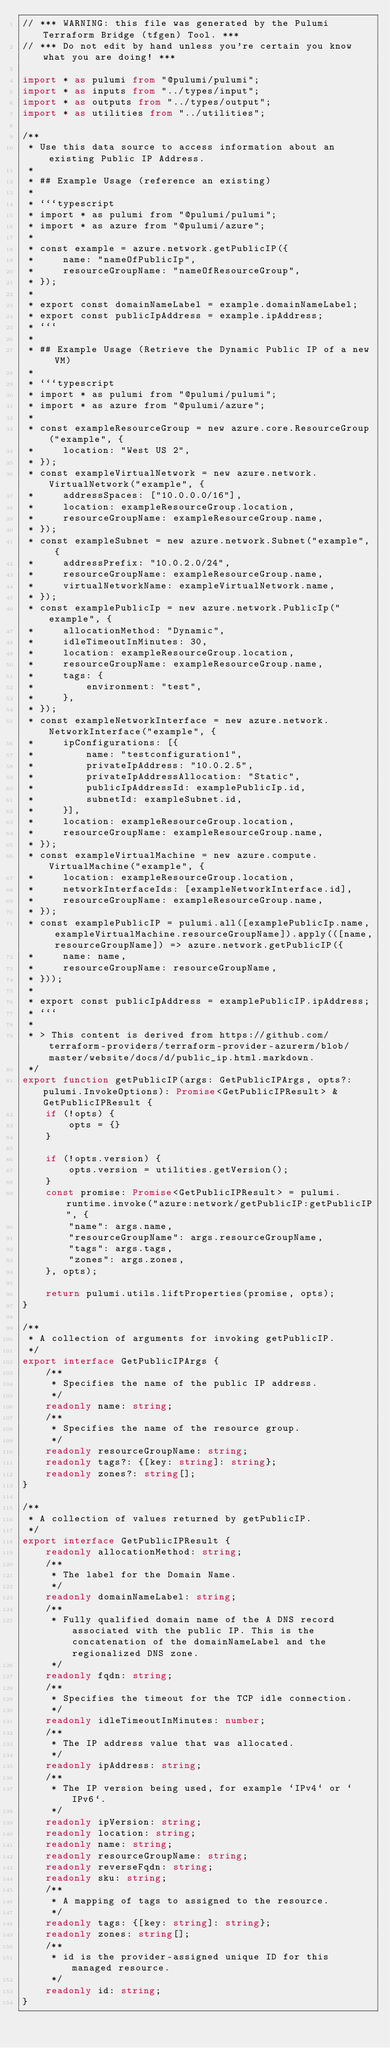Convert code to text. <code><loc_0><loc_0><loc_500><loc_500><_TypeScript_>// *** WARNING: this file was generated by the Pulumi Terraform Bridge (tfgen) Tool. ***
// *** Do not edit by hand unless you're certain you know what you are doing! ***

import * as pulumi from "@pulumi/pulumi";
import * as inputs from "../types/input";
import * as outputs from "../types/output";
import * as utilities from "../utilities";

/**
 * Use this data source to access information about an existing Public IP Address.
 * 
 * ## Example Usage (reference an existing)
 * 
 * ```typescript
 * import * as pulumi from "@pulumi/pulumi";
 * import * as azure from "@pulumi/azure";
 * 
 * const example = azure.network.getPublicIP({
 *     name: "nameOfPublicIp",
 *     resourceGroupName: "nameOfResourceGroup",
 * });
 * 
 * export const domainNameLabel = example.domainNameLabel;
 * export const publicIpAddress = example.ipAddress;
 * ```
 * 
 * ## Example Usage (Retrieve the Dynamic Public IP of a new VM)
 * 
 * ```typescript
 * import * as pulumi from "@pulumi/pulumi";
 * import * as azure from "@pulumi/azure";
 * 
 * const exampleResourceGroup = new azure.core.ResourceGroup("example", {
 *     location: "West US 2",
 * });
 * const exampleVirtualNetwork = new azure.network.VirtualNetwork("example", {
 *     addressSpaces: ["10.0.0.0/16"],
 *     location: exampleResourceGroup.location,
 *     resourceGroupName: exampleResourceGroup.name,
 * });
 * const exampleSubnet = new azure.network.Subnet("example", {
 *     addressPrefix: "10.0.2.0/24",
 *     resourceGroupName: exampleResourceGroup.name,
 *     virtualNetworkName: exampleVirtualNetwork.name,
 * });
 * const examplePublicIp = new azure.network.PublicIp("example", {
 *     allocationMethod: "Dynamic",
 *     idleTimeoutInMinutes: 30,
 *     location: exampleResourceGroup.location,
 *     resourceGroupName: exampleResourceGroup.name,
 *     tags: {
 *         environment: "test",
 *     },
 * });
 * const exampleNetworkInterface = new azure.network.NetworkInterface("example", {
 *     ipConfigurations: [{
 *         name: "testconfiguration1",
 *         privateIpAddress: "10.0.2.5",
 *         privateIpAddressAllocation: "Static",
 *         publicIpAddressId: examplePublicIp.id,
 *         subnetId: exampleSubnet.id,
 *     }],
 *     location: exampleResourceGroup.location,
 *     resourceGroupName: exampleResourceGroup.name,
 * });
 * const exampleVirtualMachine = new azure.compute.VirtualMachine("example", {
 *     location: exampleResourceGroup.location,
 *     networkInterfaceIds: [exampleNetworkInterface.id],
 *     resourceGroupName: exampleResourceGroup.name,
 * });
 * const examplePublicIP = pulumi.all([examplePublicIp.name, exampleVirtualMachine.resourceGroupName]).apply(([name, resourceGroupName]) => azure.network.getPublicIP({
 *     name: name,
 *     resourceGroupName: resourceGroupName,
 * }));
 * 
 * export const publicIpAddress = examplePublicIP.ipAddress;
 * ```
 *
 * > This content is derived from https://github.com/terraform-providers/terraform-provider-azurerm/blob/master/website/docs/d/public_ip.html.markdown.
 */
export function getPublicIP(args: GetPublicIPArgs, opts?: pulumi.InvokeOptions): Promise<GetPublicIPResult> & GetPublicIPResult {
    if (!opts) {
        opts = {}
    }

    if (!opts.version) {
        opts.version = utilities.getVersion();
    }
    const promise: Promise<GetPublicIPResult> = pulumi.runtime.invoke("azure:network/getPublicIP:getPublicIP", {
        "name": args.name,
        "resourceGroupName": args.resourceGroupName,
        "tags": args.tags,
        "zones": args.zones,
    }, opts);

    return pulumi.utils.liftProperties(promise, opts);
}

/**
 * A collection of arguments for invoking getPublicIP.
 */
export interface GetPublicIPArgs {
    /**
     * Specifies the name of the public IP address.
     */
    readonly name: string;
    /**
     * Specifies the name of the resource group.
     */
    readonly resourceGroupName: string;
    readonly tags?: {[key: string]: string};
    readonly zones?: string[];
}

/**
 * A collection of values returned by getPublicIP.
 */
export interface GetPublicIPResult {
    readonly allocationMethod: string;
    /**
     * The label for the Domain Name.
     */
    readonly domainNameLabel: string;
    /**
     * Fully qualified domain name of the A DNS record associated with the public IP. This is the concatenation of the domainNameLabel and the regionalized DNS zone.
     */
    readonly fqdn: string;
    /**
     * Specifies the timeout for the TCP idle connection.
     */
    readonly idleTimeoutInMinutes: number;
    /**
     * The IP address value that was allocated.
     */
    readonly ipAddress: string;
    /**
     * The IP version being used, for example `IPv4` or `IPv6`.
     */
    readonly ipVersion: string;
    readonly location: string;
    readonly name: string;
    readonly resourceGroupName: string;
    readonly reverseFqdn: string;
    readonly sku: string;
    /**
     * A mapping of tags to assigned to the resource.
     */
    readonly tags: {[key: string]: string};
    readonly zones: string[];
    /**
     * id is the provider-assigned unique ID for this managed resource.
     */
    readonly id: string;
}
</code> 